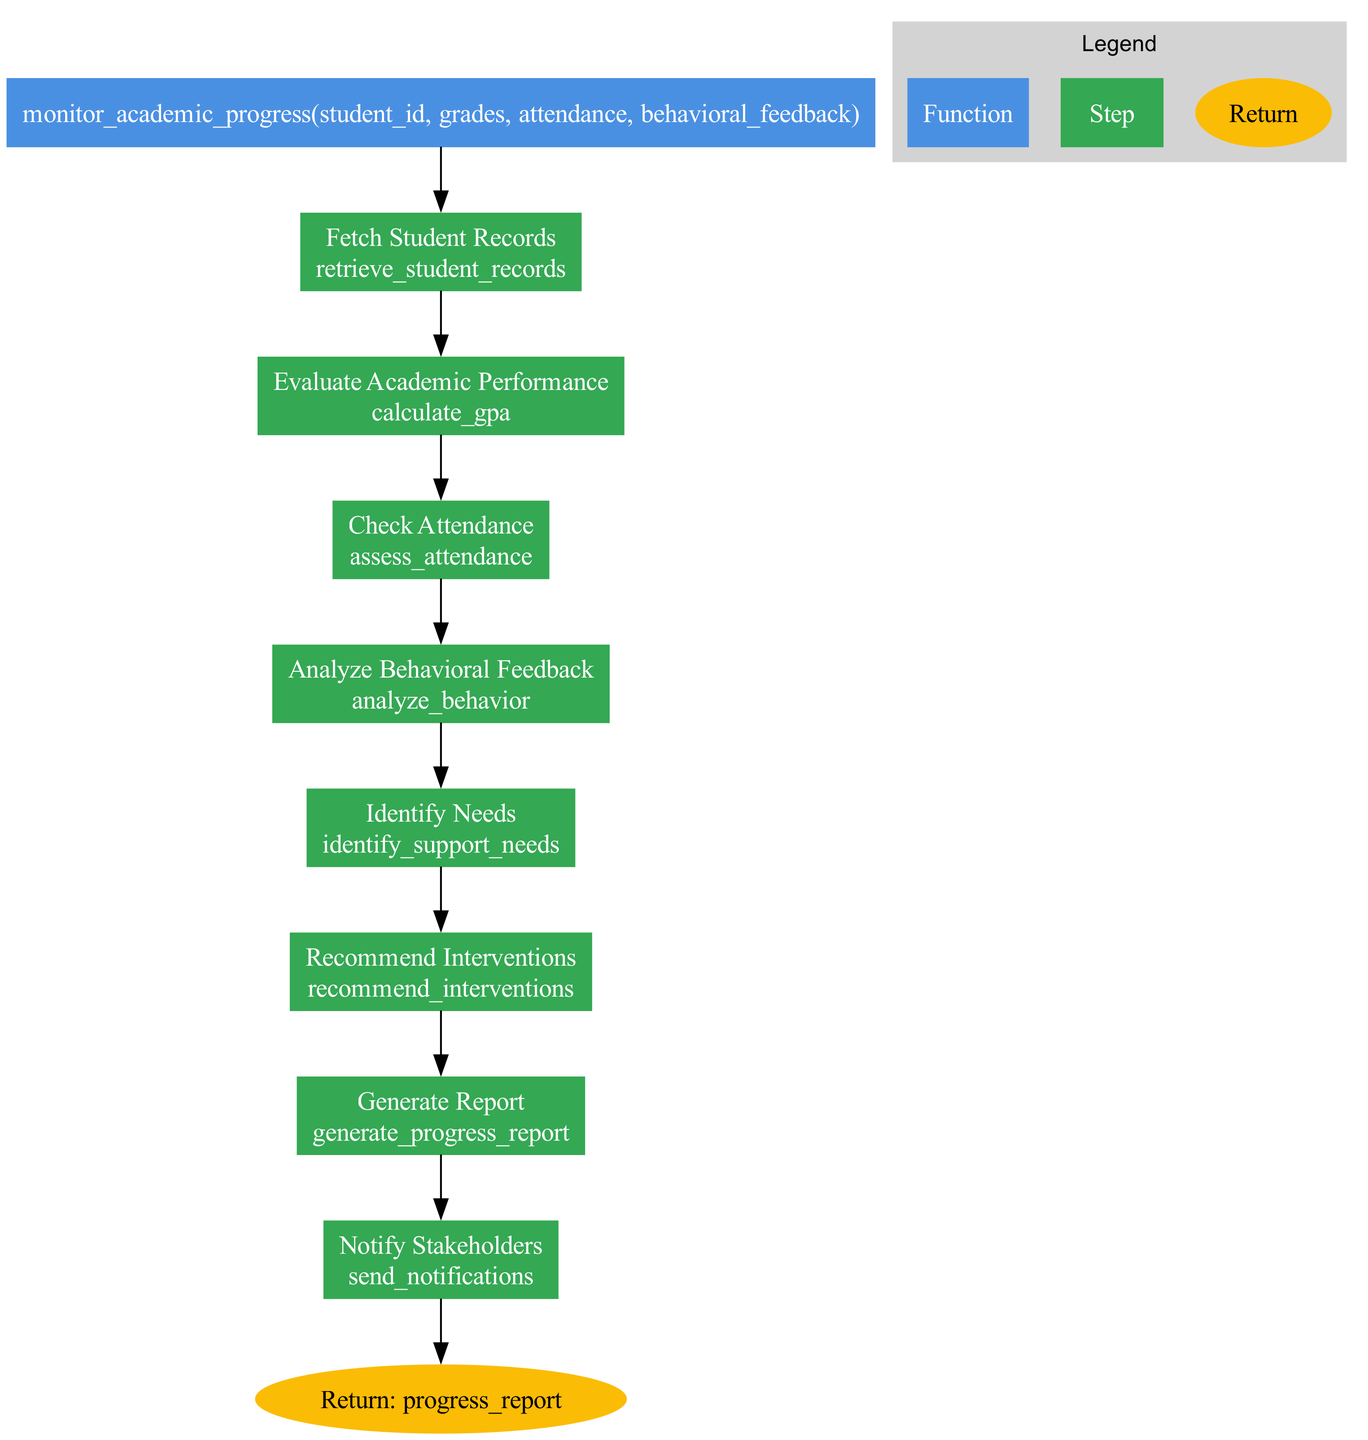What is the function name in the diagram? The diagram specifies the function name at the start, indicated in the box labeled 'function'. It states "monitor_academic_progress".
Answer: monitor_academic_progress How many steps are there in the academic progress monitoring process? By counting the nodes representing steps in the diagram, there are a total of eight steps from 'Fetch Student Records' to 'Notify Stakeholders'.
Answer: 8 What action comes after "Check Attendance"? In the sequence of actions illustrated in the diagram, "Analyze Behavioral Feedback" is the step that follows "Check Attendance".
Answer: Analyze Behavioral Feedback What type of interventions are recommended in the process? The diagram specifies that the step "Recommend Interventions" involves suggesting supportive interventions, which could include tutoring, counseling, or mentorship programs.
Answer: Tutoring, counseling, mentorship What is the return value of the function? At the end of the flowchart, the node labeled 'Return' indicates that the function will output a value named "progress_report".
Answer: progress_report Which step first assesses the student’s performance? The first step that evaluates or assesses the student’s performance is "Evaluate Academic Performance", where the GPA is calculated.
Answer: Evaluate Academic Performance What is the relationship between "Identify Needs" and "Recommend Interventions"? "Identify Needs" precedes "Recommend Interventions" in the flowchart; this indicates that identifying support needs is a prerequisite for recommending appropriate interventions.
Answer: Preceding relationship What is the final action taken in the process? The last action in the flowchart is represented by the "Notify Stakeholders" step, which indicates that stakeholders will be informed of the results after the other steps are completed.
Answer: Notify Stakeholders 